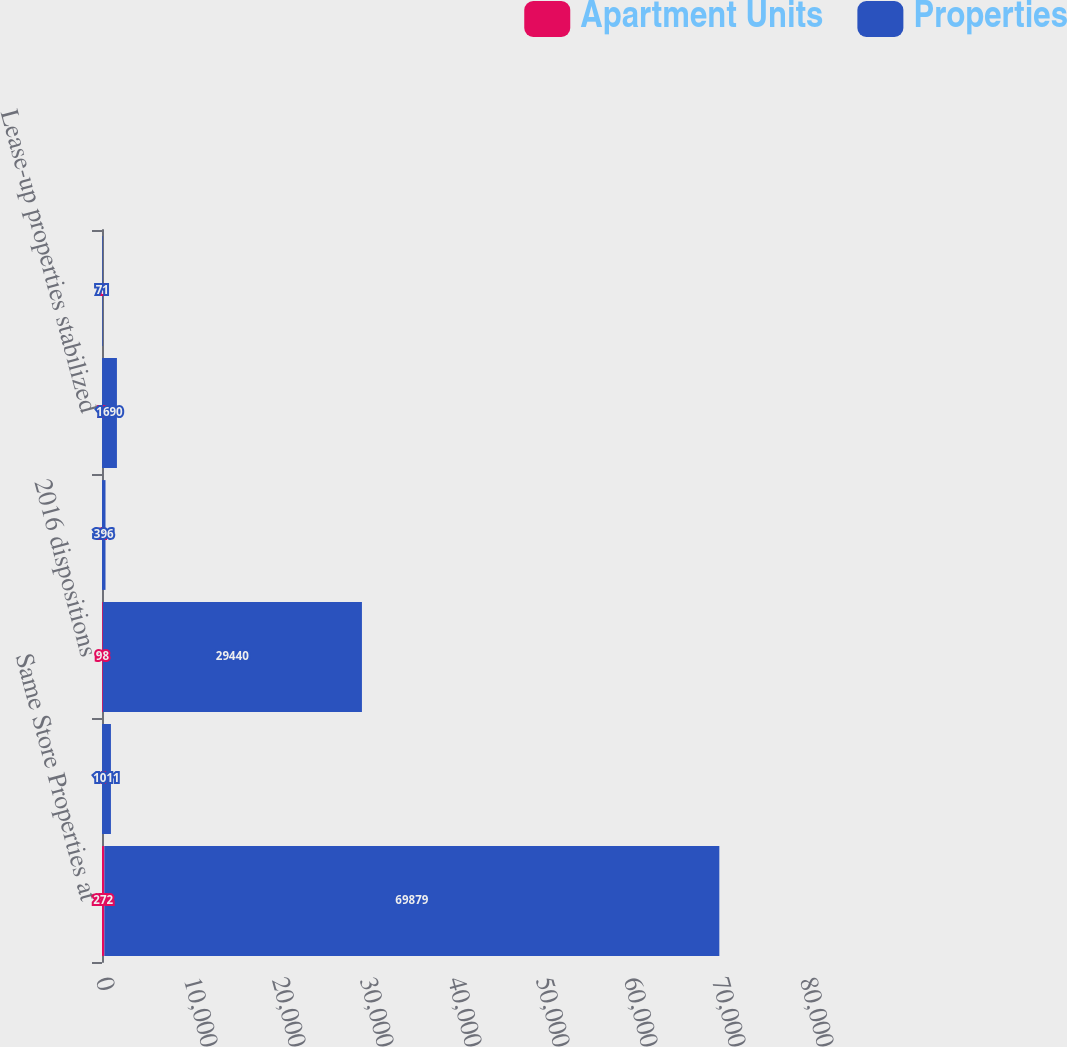Convert chart to OTSL. <chart><loc_0><loc_0><loc_500><loc_500><stacked_bar_chart><ecel><fcel>Same Store Properties at<fcel>2014 acquisitions<fcel>2016 dispositions<fcel>2016 dispositions not yet<fcel>Lease-up properties stabilized<fcel>Properties removed from same<nl><fcel>Apartment Units<fcel>272<fcel>4<fcel>98<fcel>2<fcel>7<fcel>1<nl><fcel>Properties<fcel>69879<fcel>1011<fcel>29440<fcel>396<fcel>1690<fcel>71<nl></chart> 